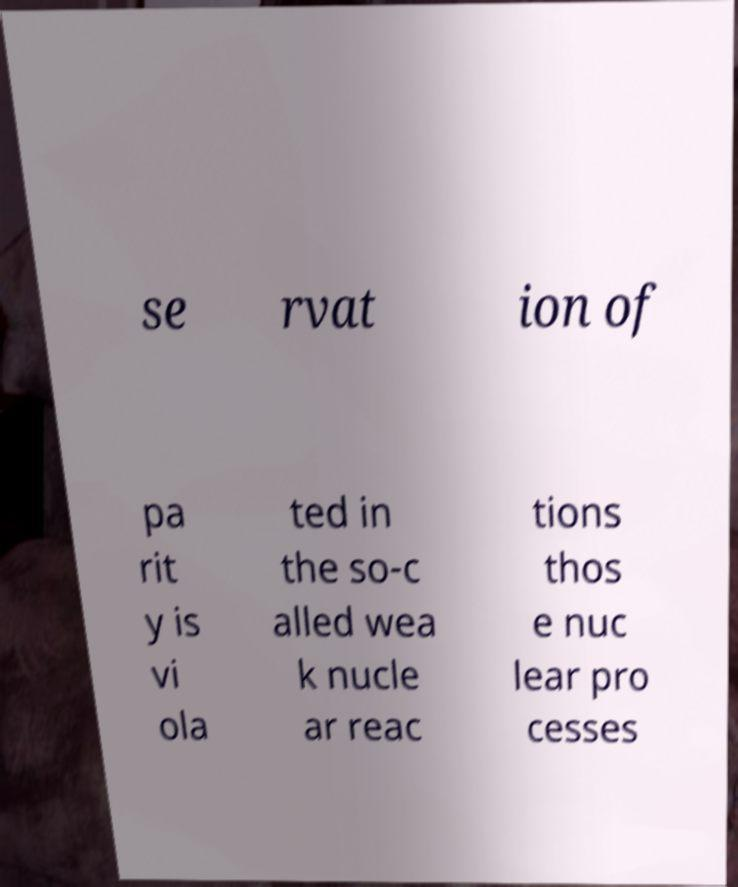Could you assist in decoding the text presented in this image and type it out clearly? se rvat ion of pa rit y is vi ola ted in the so-c alled wea k nucle ar reac tions thos e nuc lear pro cesses 